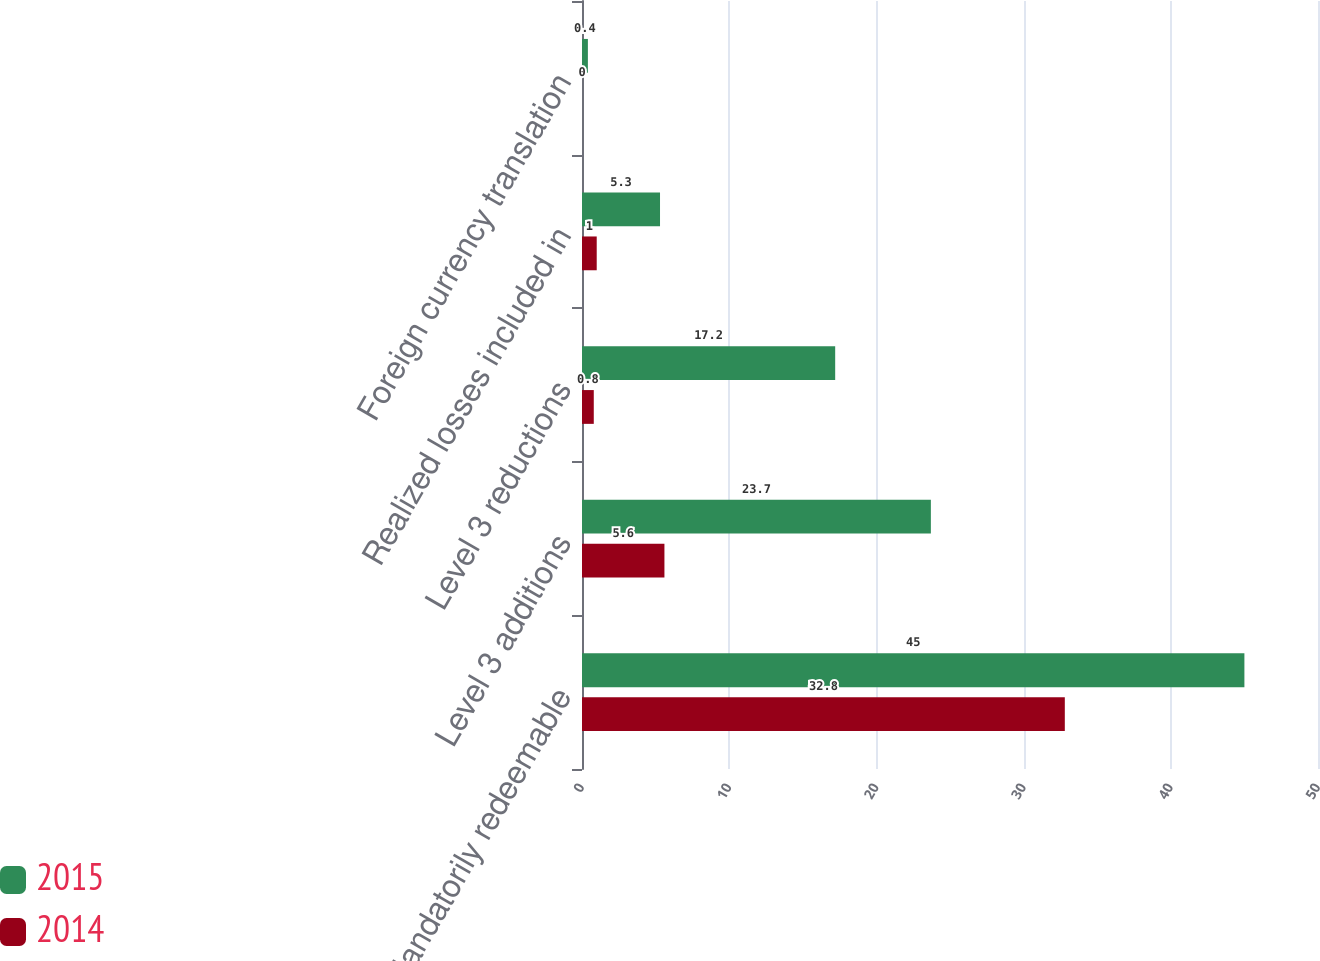Convert chart to OTSL. <chart><loc_0><loc_0><loc_500><loc_500><stacked_bar_chart><ecel><fcel>Mandatorily redeemable<fcel>Level 3 additions<fcel>Level 3 reductions<fcel>Realized losses included in<fcel>Foreign currency translation<nl><fcel>2015<fcel>45<fcel>23.7<fcel>17.2<fcel>5.3<fcel>0.4<nl><fcel>2014<fcel>32.8<fcel>5.6<fcel>0.8<fcel>1<fcel>0<nl></chart> 